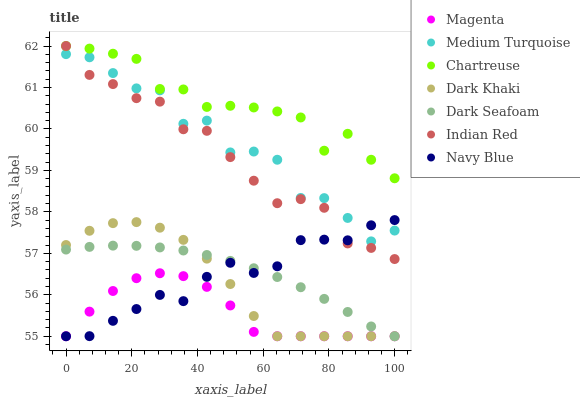Does Magenta have the minimum area under the curve?
Answer yes or no. Yes. Does Chartreuse have the maximum area under the curve?
Answer yes or no. Yes. Does Navy Blue have the minimum area under the curve?
Answer yes or no. No. Does Navy Blue have the maximum area under the curve?
Answer yes or no. No. Is Dark Seafoam the smoothest?
Answer yes or no. Yes. Is Medium Turquoise the roughest?
Answer yes or no. Yes. Is Navy Blue the smoothest?
Answer yes or no. No. Is Navy Blue the roughest?
Answer yes or no. No. Does Navy Blue have the lowest value?
Answer yes or no. Yes. Does Chartreuse have the lowest value?
Answer yes or no. No. Does Indian Red have the highest value?
Answer yes or no. Yes. Does Navy Blue have the highest value?
Answer yes or no. No. Is Dark Seafoam less than Medium Turquoise?
Answer yes or no. Yes. Is Indian Red greater than Dark Khaki?
Answer yes or no. Yes. Does Magenta intersect Navy Blue?
Answer yes or no. Yes. Is Magenta less than Navy Blue?
Answer yes or no. No. Is Magenta greater than Navy Blue?
Answer yes or no. No. Does Dark Seafoam intersect Medium Turquoise?
Answer yes or no. No. 